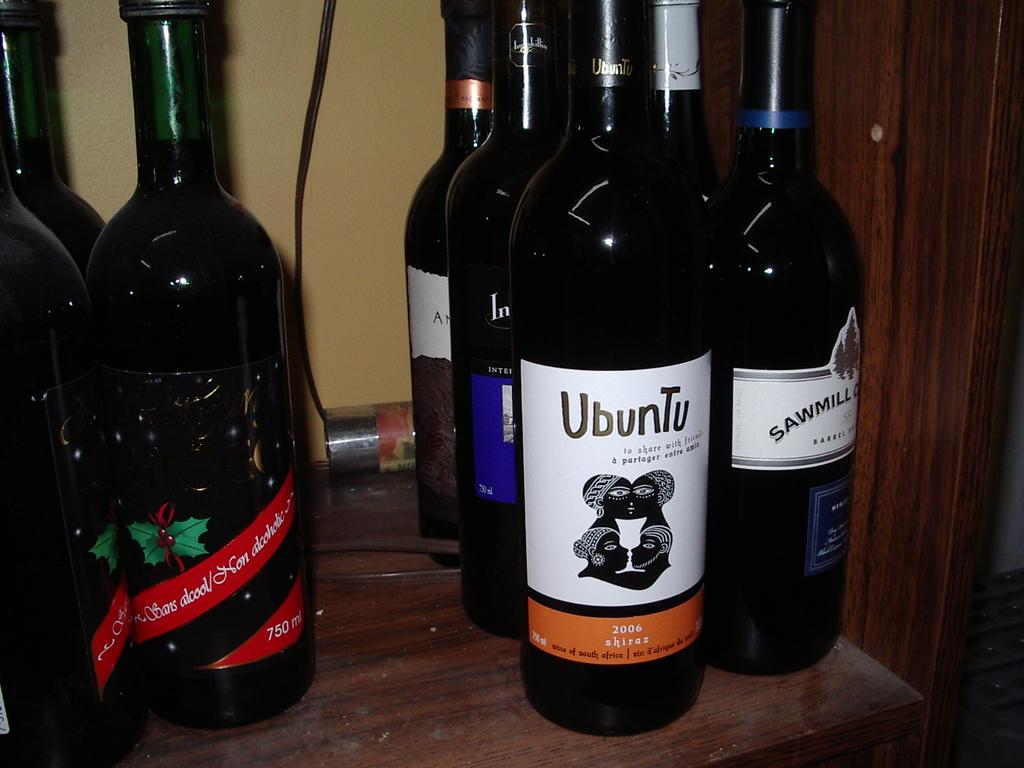<image>
Offer a succinct explanation of the picture presented. A bottle of Ubuntu Shiraz wine sits in front of other bottles. 